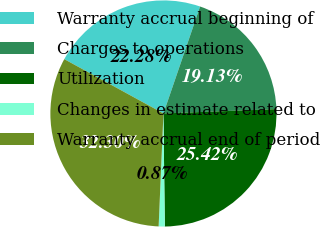Convert chart to OTSL. <chart><loc_0><loc_0><loc_500><loc_500><pie_chart><fcel>Warranty accrual beginning of<fcel>Charges to operations<fcel>Utilization<fcel>Changes in estimate related to<fcel>Warranty accrual end of period<nl><fcel>22.28%<fcel>19.13%<fcel>25.42%<fcel>0.87%<fcel>32.3%<nl></chart> 